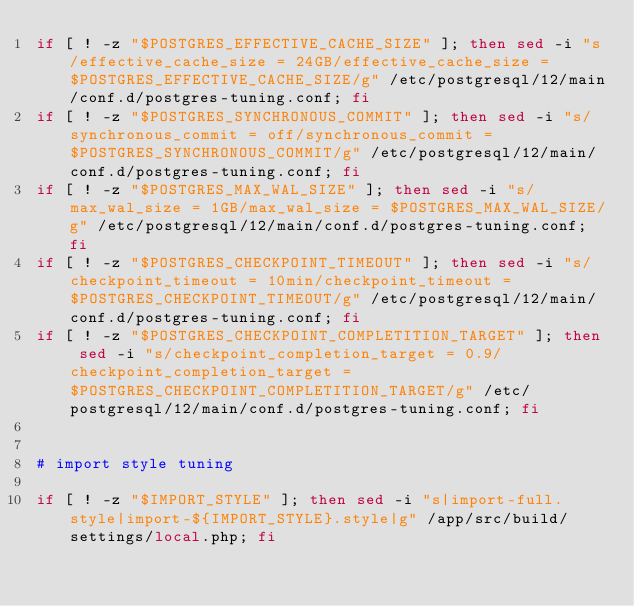<code> <loc_0><loc_0><loc_500><loc_500><_Bash_>if [ ! -z "$POSTGRES_EFFECTIVE_CACHE_SIZE" ]; then sed -i "s/effective_cache_size = 24GB/effective_cache_size = $POSTGRES_EFFECTIVE_CACHE_SIZE/g" /etc/postgresql/12/main/conf.d/postgres-tuning.conf; fi
if [ ! -z "$POSTGRES_SYNCHRONOUS_COMMIT" ]; then sed -i "s/synchronous_commit = off/synchronous_commit = $POSTGRES_SYNCHRONOUS_COMMIT/g" /etc/postgresql/12/main/conf.d/postgres-tuning.conf; fi
if [ ! -z "$POSTGRES_MAX_WAL_SIZE" ]; then sed -i "s/max_wal_size = 1GB/max_wal_size = $POSTGRES_MAX_WAL_SIZE/g" /etc/postgresql/12/main/conf.d/postgres-tuning.conf; fi
if [ ! -z "$POSTGRES_CHECKPOINT_TIMEOUT" ]; then sed -i "s/checkpoint_timeout = 10min/checkpoint_timeout = $POSTGRES_CHECKPOINT_TIMEOUT/g" /etc/postgresql/12/main/conf.d/postgres-tuning.conf; fi
if [ ! -z "$POSTGRES_CHECKPOINT_COMPLETITION_TARGET" ]; then sed -i "s/checkpoint_completion_target = 0.9/checkpoint_completion_target = $POSTGRES_CHECKPOINT_COMPLETITION_TARGET/g" /etc/postgresql/12/main/conf.d/postgres-tuning.conf; fi


# import style tuning

if [ ! -z "$IMPORT_STYLE" ]; then sed -i "s|import-full.style|import-${IMPORT_STYLE}.style|g" /app/src/build/settings/local.php; fi
</code> 